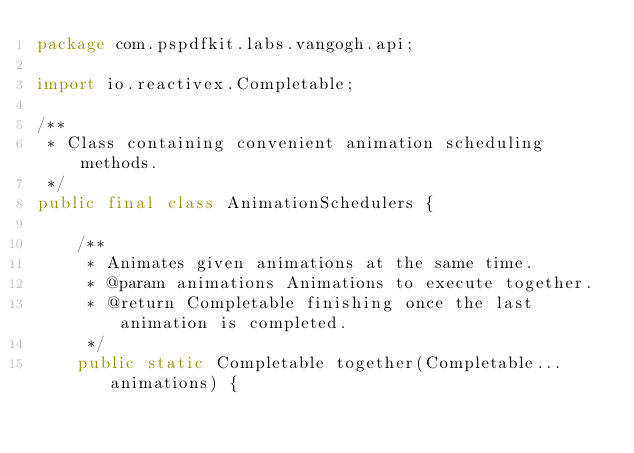Convert code to text. <code><loc_0><loc_0><loc_500><loc_500><_Java_>package com.pspdfkit.labs.vangogh.api;

import io.reactivex.Completable;

/**
 * Class containing convenient animation scheduling methods.
 */
public final class AnimationSchedulers {

    /**
     * Animates given animations at the same time.
     * @param animations Animations to execute together.
     * @return Completable finishing once the last animation is completed.
     */
    public static Completable together(Completable... animations) {</code> 